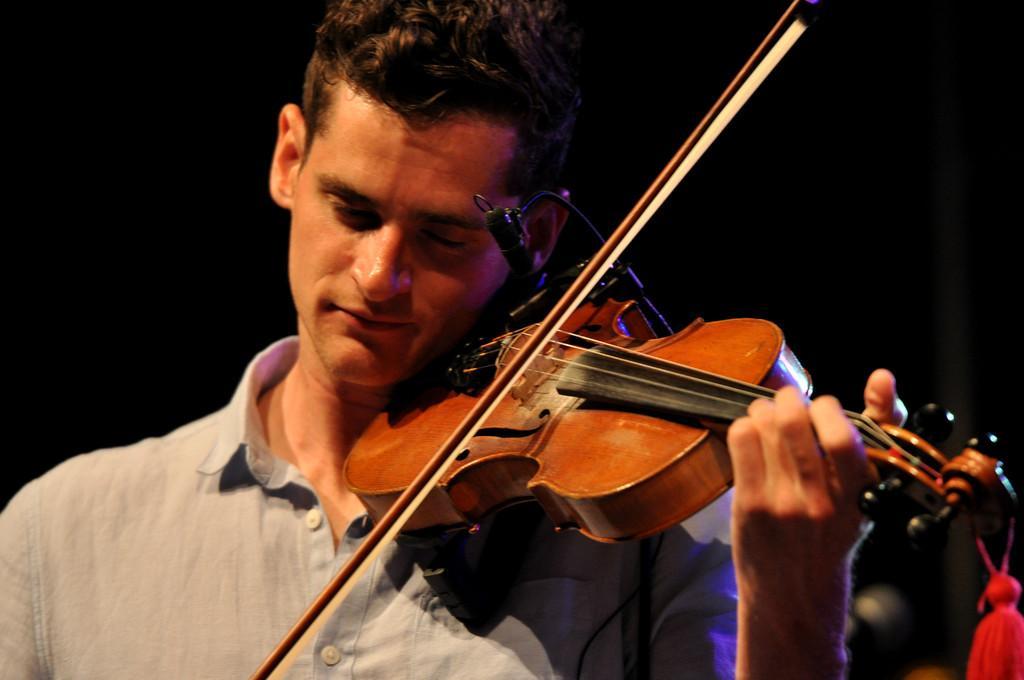Could you give a brief overview of what you see in this image? In the center of the image we can see a man playing a violin. 